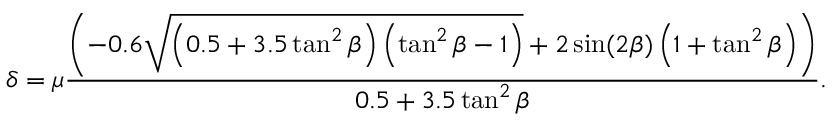<formula> <loc_0><loc_0><loc_500><loc_500>\delta = \mu \frac { \left ( - 0 . 6 \sqrt { \left ( 0 . 5 + 3 . 5 \tan ^ { 2 } \beta \right ) \left ( \tan ^ { 2 } \beta - 1 \right ) } + 2 \sin ( 2 \beta ) \left ( 1 + \tan ^ { 2 } \beta \right ) \right ) } { 0 . 5 + 3 . 5 \tan ^ { 2 } \beta } .</formula> 